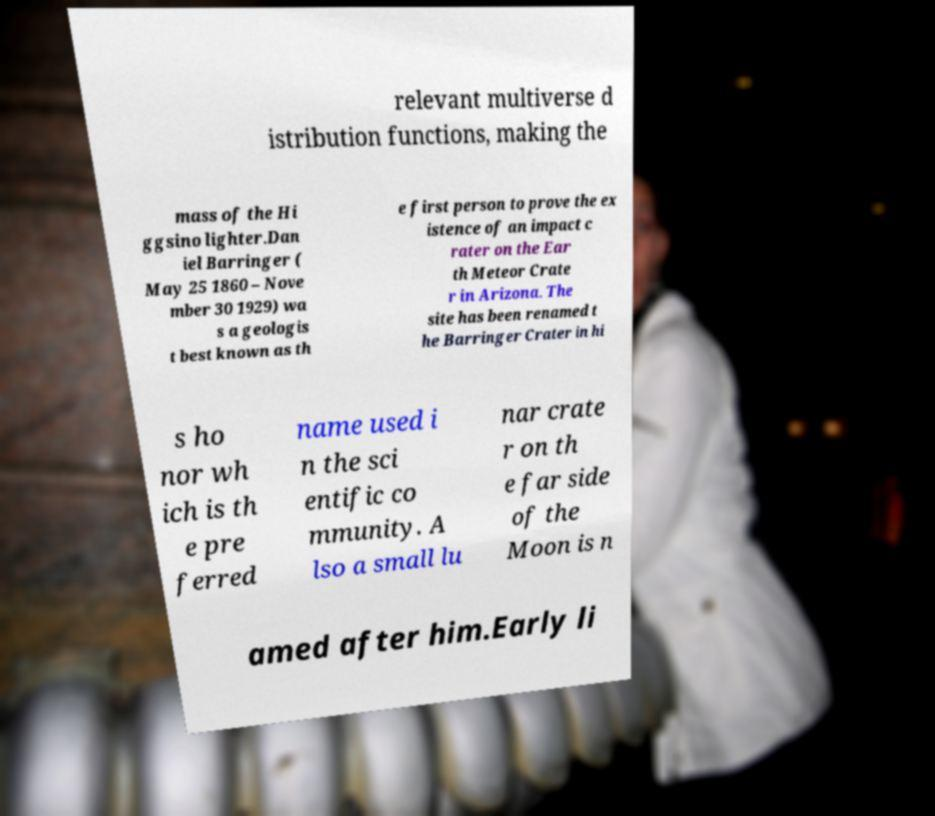What messages or text are displayed in this image? I need them in a readable, typed format. relevant multiverse d istribution functions, making the mass of the Hi ggsino lighter.Dan iel Barringer ( May 25 1860 – Nove mber 30 1929) wa s a geologis t best known as th e first person to prove the ex istence of an impact c rater on the Ear th Meteor Crate r in Arizona. The site has been renamed t he Barringer Crater in hi s ho nor wh ich is th e pre ferred name used i n the sci entific co mmunity. A lso a small lu nar crate r on th e far side of the Moon is n amed after him.Early li 